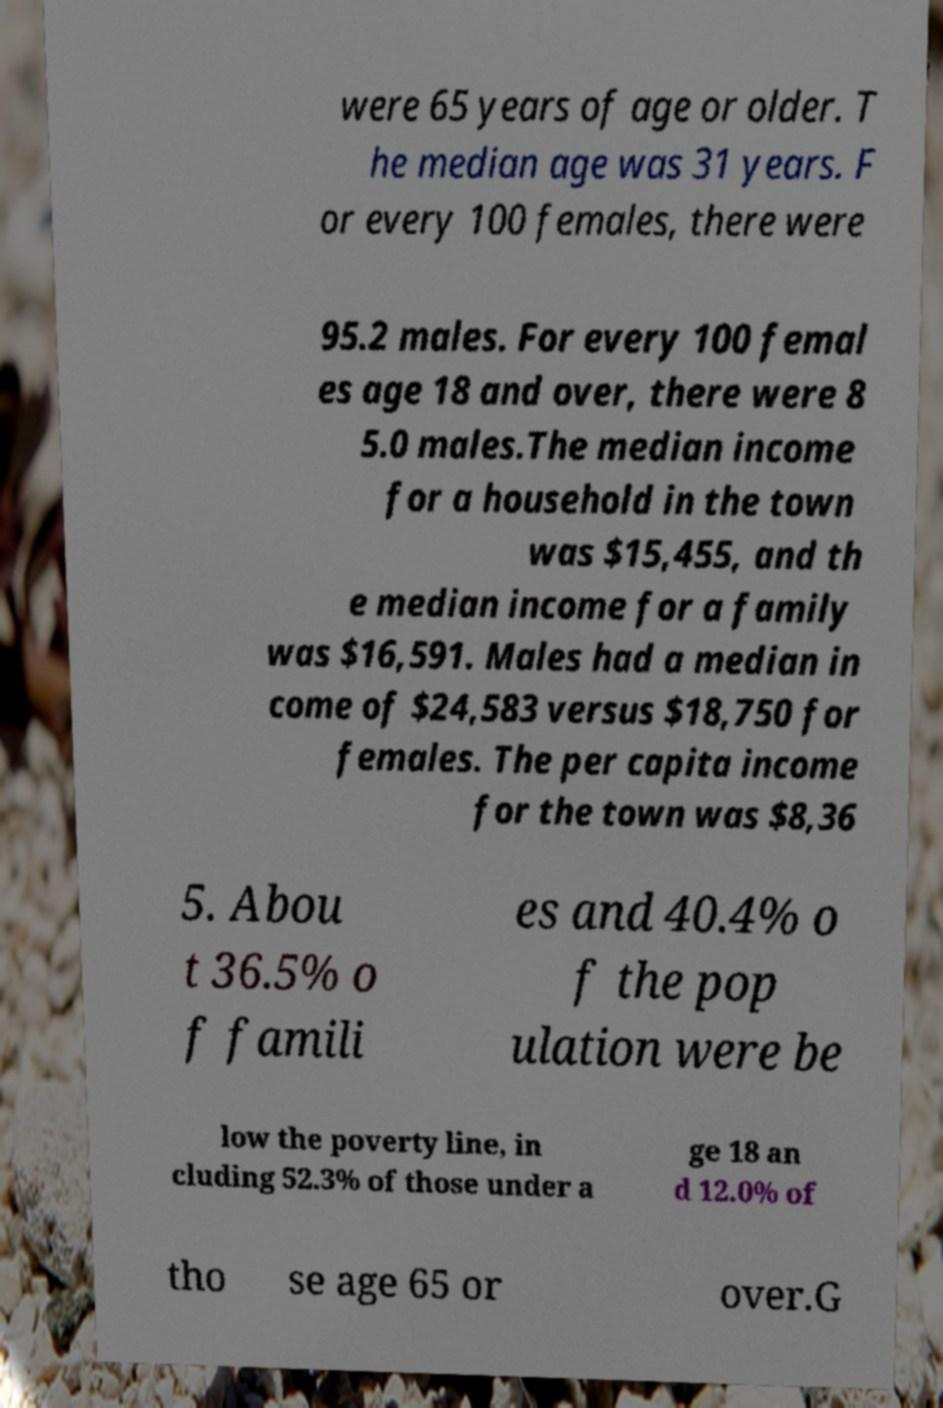Could you extract and type out the text from this image? were 65 years of age or older. T he median age was 31 years. F or every 100 females, there were 95.2 males. For every 100 femal es age 18 and over, there were 8 5.0 males.The median income for a household in the town was $15,455, and th e median income for a family was $16,591. Males had a median in come of $24,583 versus $18,750 for females. The per capita income for the town was $8,36 5. Abou t 36.5% o f famili es and 40.4% o f the pop ulation were be low the poverty line, in cluding 52.3% of those under a ge 18 an d 12.0% of tho se age 65 or over.G 